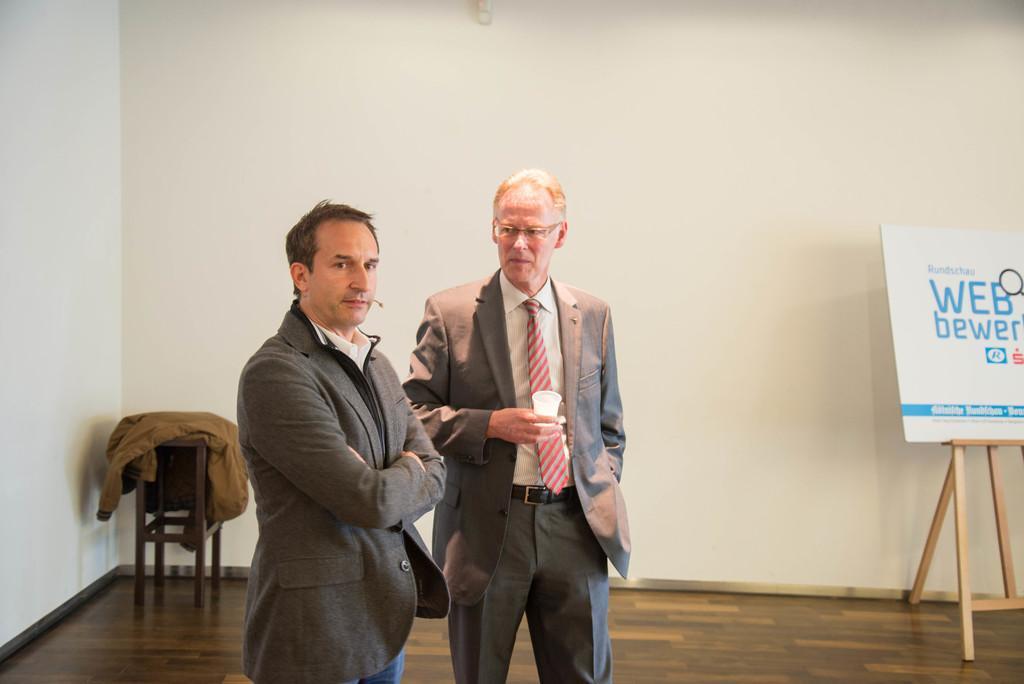Please provide a concise description of this image. On the background we can see a wall and a jacket on a chair, whiteboard with stand. This is a floor. We can see two men standing here. This man is holding a glass in his hand. 